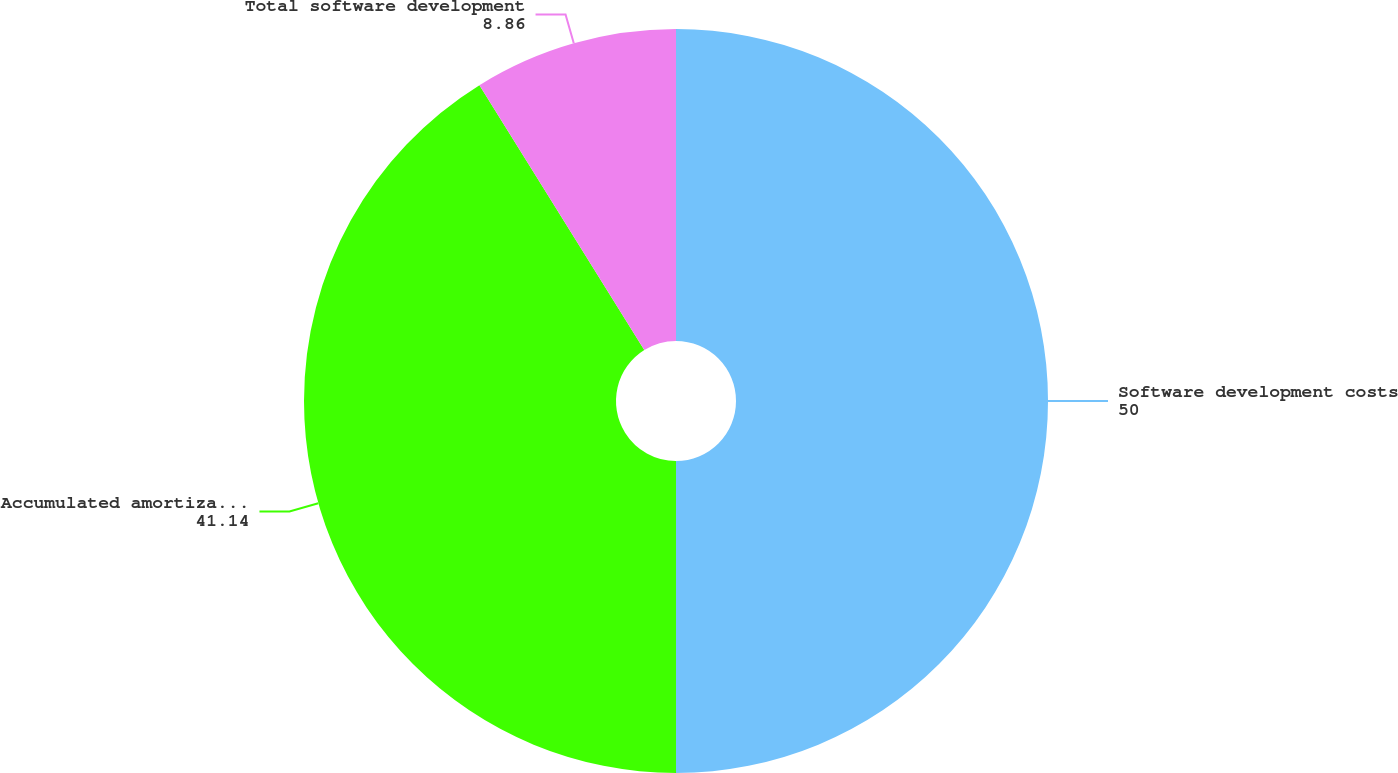Convert chart. <chart><loc_0><loc_0><loc_500><loc_500><pie_chart><fcel>Software development costs<fcel>Accumulated amortization<fcel>Total software development<nl><fcel>50.0%<fcel>41.14%<fcel>8.86%<nl></chart> 